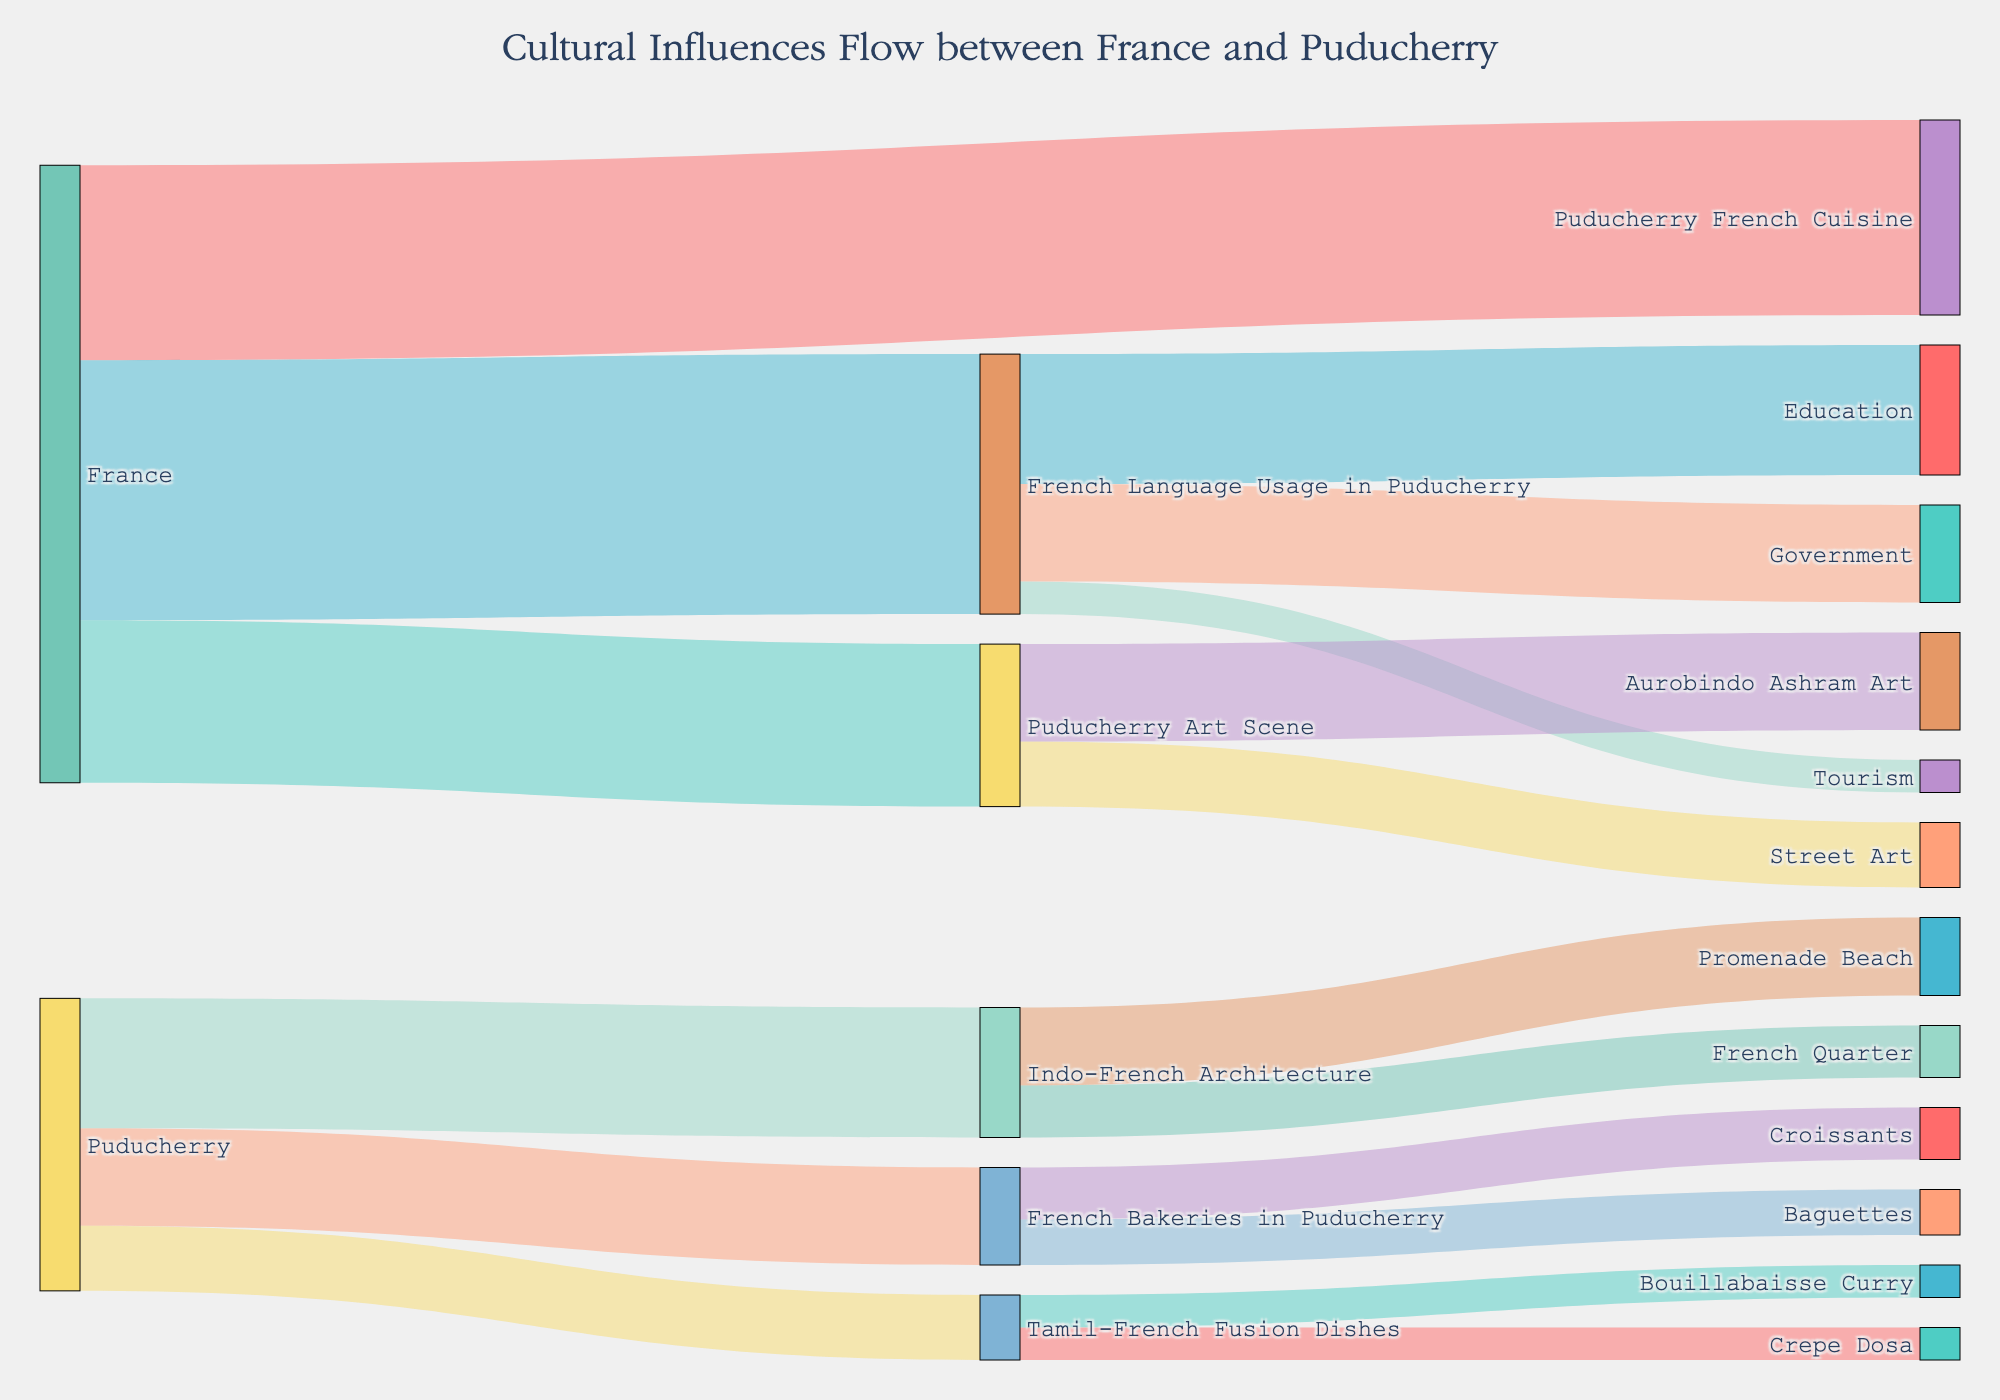How many unique cultural influences flow from France to Puducherry? To find this, look at the arrows originating from 'France' and count the unique targets (Puducherry French Cuisine, Puducherry Art Scene, French Language Usage in Puducherry). There are 3 arrows hence 3 unique influences.
Answer: 3 What is the overall value of cultural influences flowing from Puducherry to its various domains? Add the values for all arrows originating from 'Puducherry' (15 + 20 + 10 = 45).
Answer: 45 Comparing France's influence on 'Puducherry Art Scene' and 'Puducherry French Cuisine', which is greater and by how much? 'Puducherry Art Scene' has a value of 25, and 'Puducherry French Cuisine' has a value of 30. The difference is 30 - 25 = 5.
Answer: Puducherry French Cuisine by 5 Which specific target within 'French Language Usage in Puducherry' has the highest value? Looking at the targets within 'French Language Usage in Puducherry', Education, Government, and Tourism have values of 20, 15, and 5 respectively. The highest value is Education with 20.
Answer: Education What is the sum of the values for 'Tamil-French Fusion Dishes' and 'Indo-French Architecture'? Add the values of targets within each group: Tamil-French Fusion Dishes has 'Crepe Dosa' and 'Bouillabaisse Curry' (5 + 5 = 10). Indo-French Architecture has 'Promenade Beach' and 'French Quarter' (12 + 8 = 20). The sum is 10 + 20 = 30.
Answer: 30 Among the items influenced by 'Indo-French Architecture', which has a lower value, 'Promenade Beach' or 'French Quarter'? 'Promenade Beach' has a value of 12, and 'French Quarter' has a value of 8. Hence, 'French Quarter' has the lower value.
Answer: French Quarter How many unique items flow into 'French Language Usage in Puducherry'? Look at the arrows that lead into 'French Language Usage in Puducherry' from its various sources (Education, Government, Tourism). There are 3 arrows hence 3 unique items.
Answer: 3 What are the total values of cultural influences in 'Puducherry Art Scene'? Look at the arrows pointing to 'Street Art’ and 'Aurobindo Ashram Art' within 'Puducherry Art Scene' and sum up their values (10 + 15 = 25).
Answer: 25 